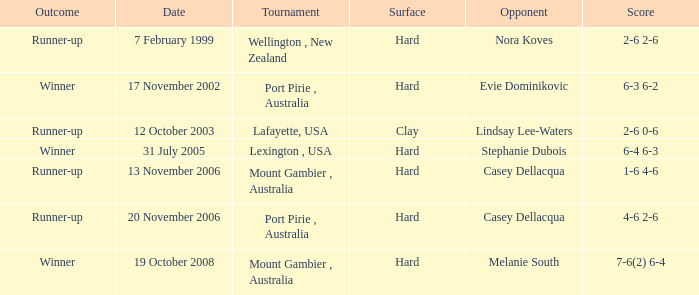What result does an adversary of lindsay lee-waters have? Runner-up. 